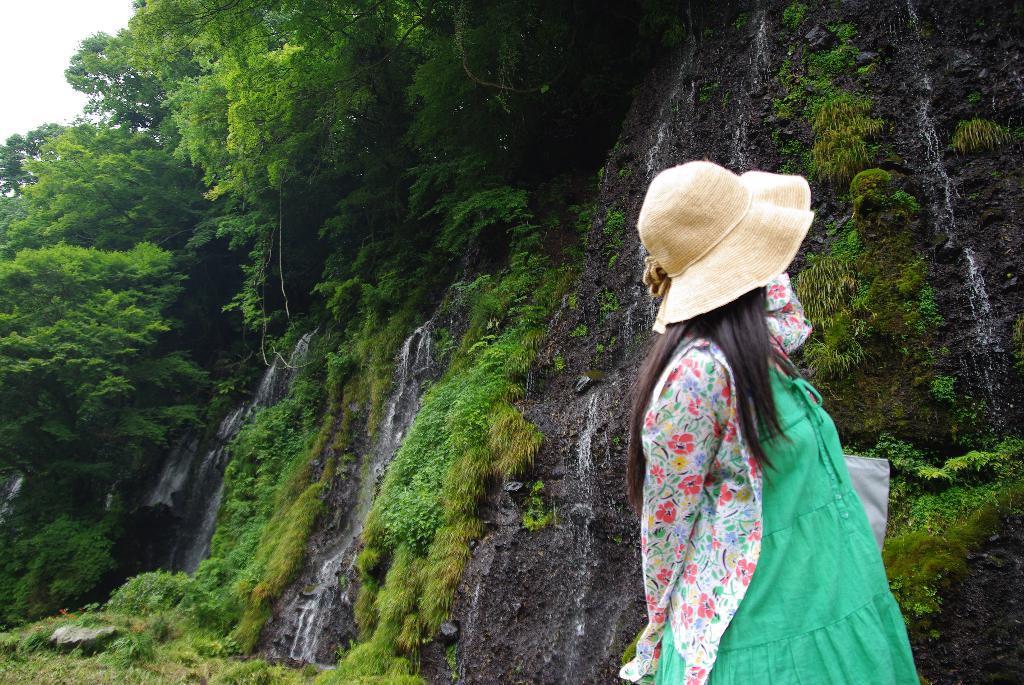Describe this image in one or two sentences. In this picture we can see a woman,she is wearing a hat and in the background we can see trees. 